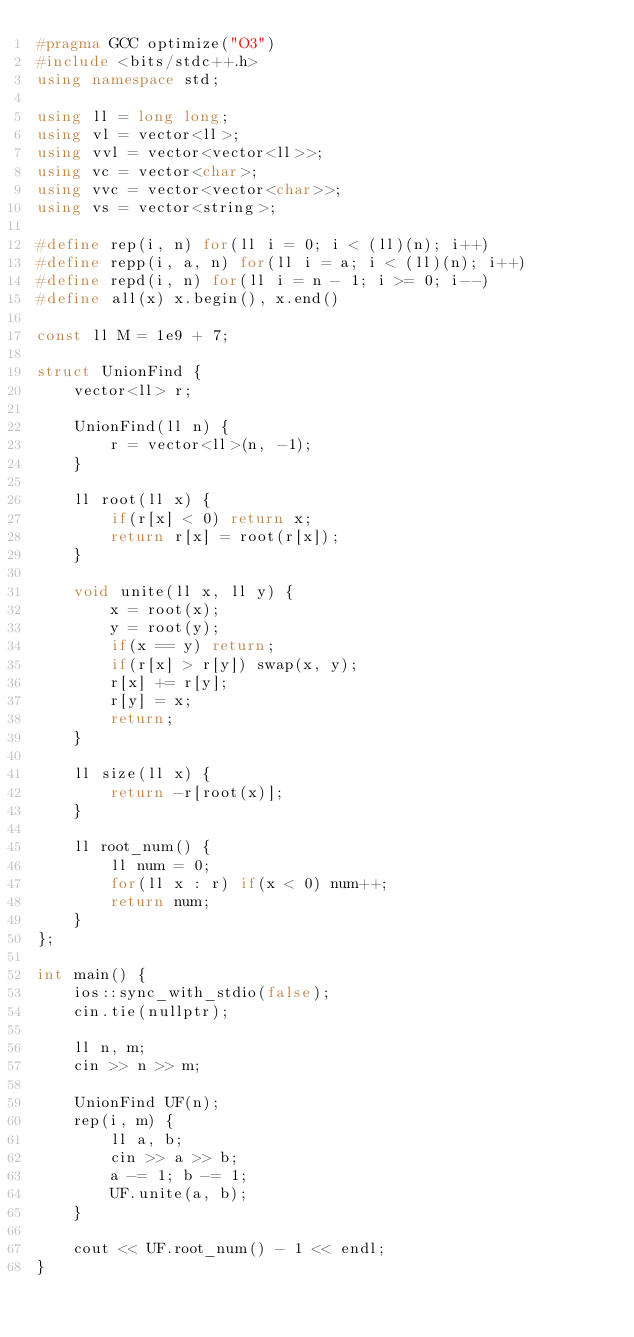<code> <loc_0><loc_0><loc_500><loc_500><_C++_>#pragma GCC optimize("O3")
#include <bits/stdc++.h>
using namespace std;

using ll = long long;
using vl = vector<ll>;
using vvl = vector<vector<ll>>;
using vc = vector<char>;
using vvc = vector<vector<char>>;
using vs = vector<string>;

#define rep(i, n) for(ll i = 0; i < (ll)(n); i++)
#define repp(i, a, n) for(ll i = a; i < (ll)(n); i++)
#define repd(i, n) for(ll i = n - 1; i >= 0; i--)
#define all(x) x.begin(), x.end()

const ll M = 1e9 + 7;

struct UnionFind {
    vector<ll> r;

    UnionFind(ll n) {
        r = vector<ll>(n, -1);
    }

    ll root(ll x) {
        if(r[x] < 0) return x;
        return r[x] = root(r[x]);
    }

    void unite(ll x, ll y) {
        x = root(x);
        y = root(y);
        if(x == y) return;
        if(r[x] > r[y]) swap(x, y);
        r[x] += r[y];
        r[y] = x;
        return;
    }

    ll size(ll x) {
        return -r[root(x)];
    }

    ll root_num() {
        ll num = 0;
        for(ll x : r) if(x < 0) num++;
        return num;
    }
};

int main() {
    ios::sync_with_stdio(false);
    cin.tie(nullptr);

    ll n, m;
    cin >> n >> m;

    UnionFind UF(n);
    rep(i, m) {
        ll a, b;
        cin >> a >> b;
        a -= 1; b -= 1;
        UF.unite(a, b);
    }

    cout << UF.root_num() - 1 << endl;
}</code> 